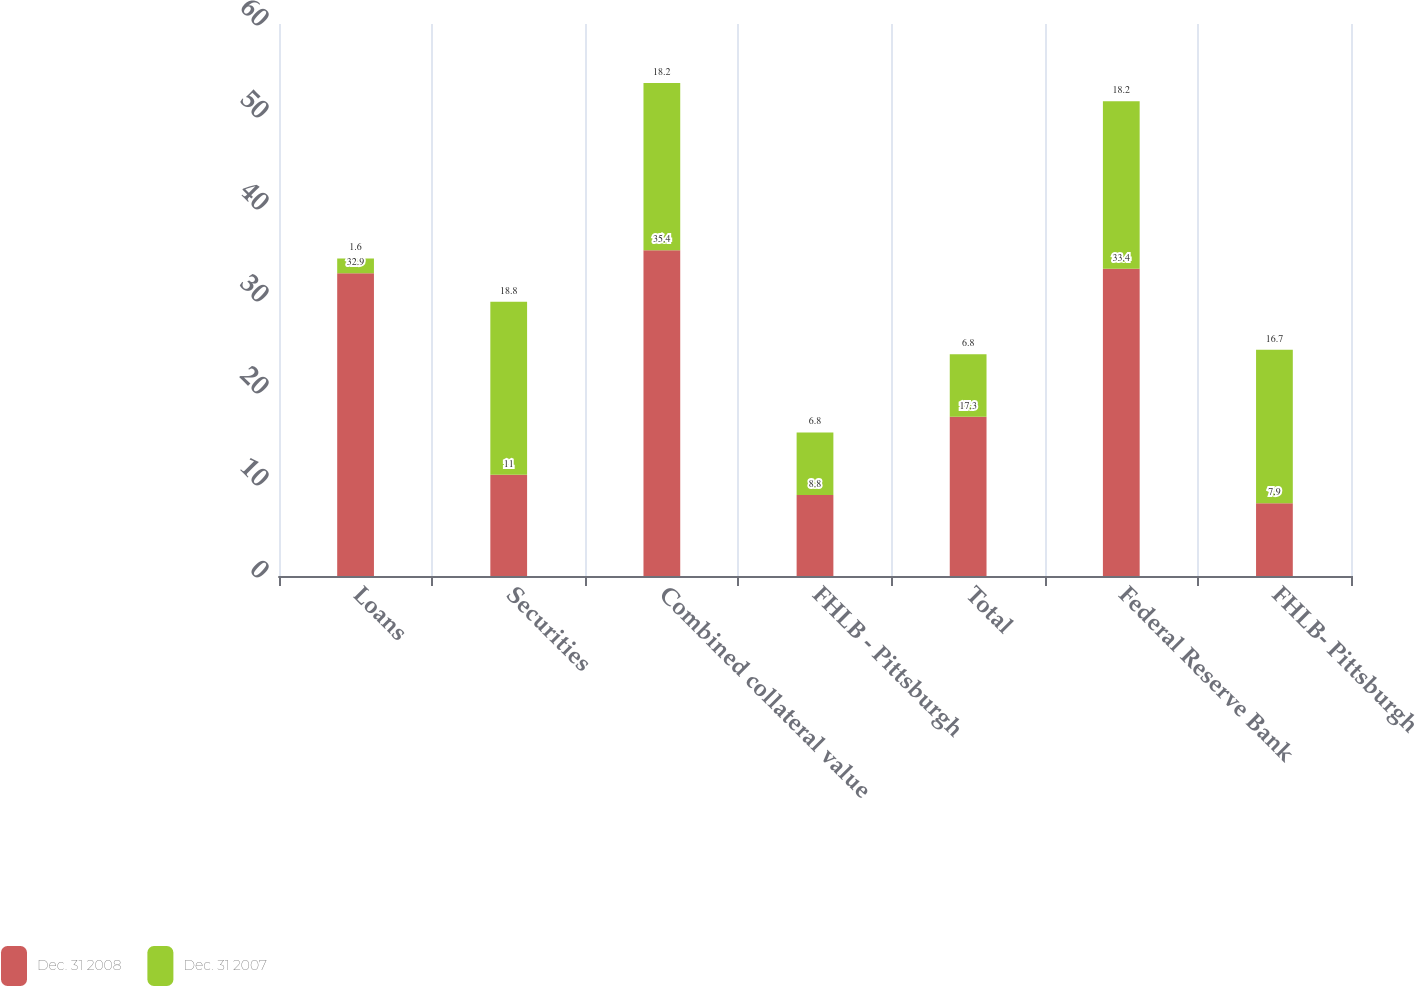Convert chart. <chart><loc_0><loc_0><loc_500><loc_500><stacked_bar_chart><ecel><fcel>Loans<fcel>Securities<fcel>Combined collateral value<fcel>FHLB - Pittsburgh<fcel>Total<fcel>Federal Reserve Bank<fcel>FHLB- Pittsburgh<nl><fcel>Dec. 31 2008<fcel>32.9<fcel>11<fcel>35.4<fcel>8.8<fcel>17.3<fcel>33.4<fcel>7.9<nl><fcel>Dec. 31 2007<fcel>1.6<fcel>18.8<fcel>18.2<fcel>6.8<fcel>6.8<fcel>18.2<fcel>16.7<nl></chart> 